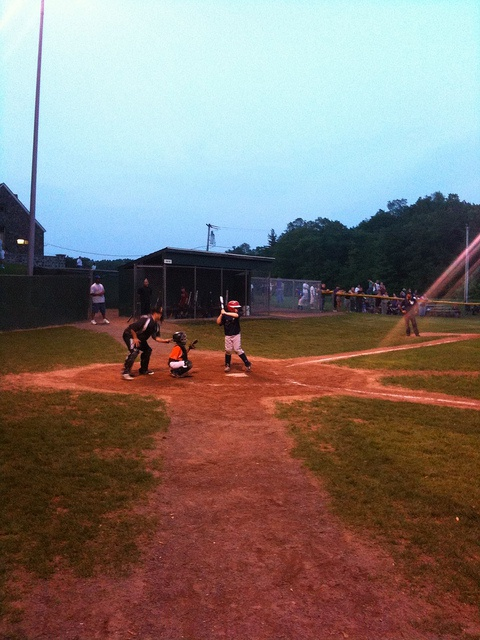Describe the objects in this image and their specific colors. I can see people in lightblue, black, maroon, and brown tones, people in lightblue, black, lightpink, maroon, and brown tones, people in lightblue, black, maroon, and red tones, people in lightblue, black, purple, maroon, and gray tones, and people in lightblue, maroon, black, and brown tones in this image. 